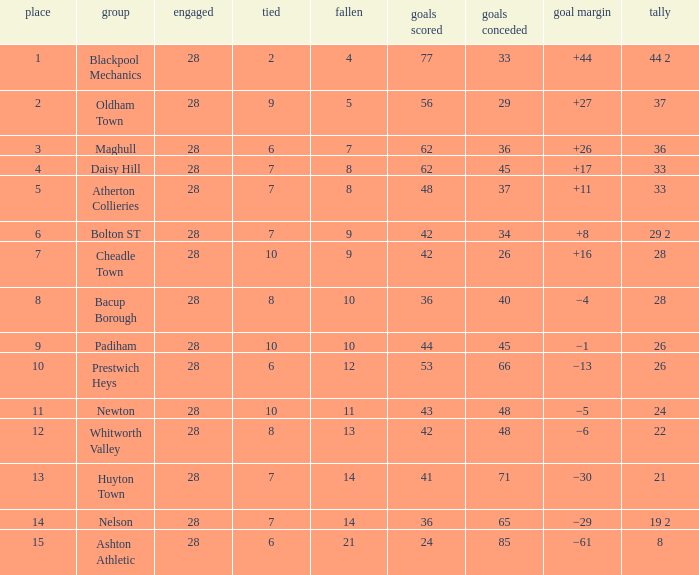What is the average played for entries with fewer than 65 goals against, points 1 of 19 2, and a position higher than 15? None. 